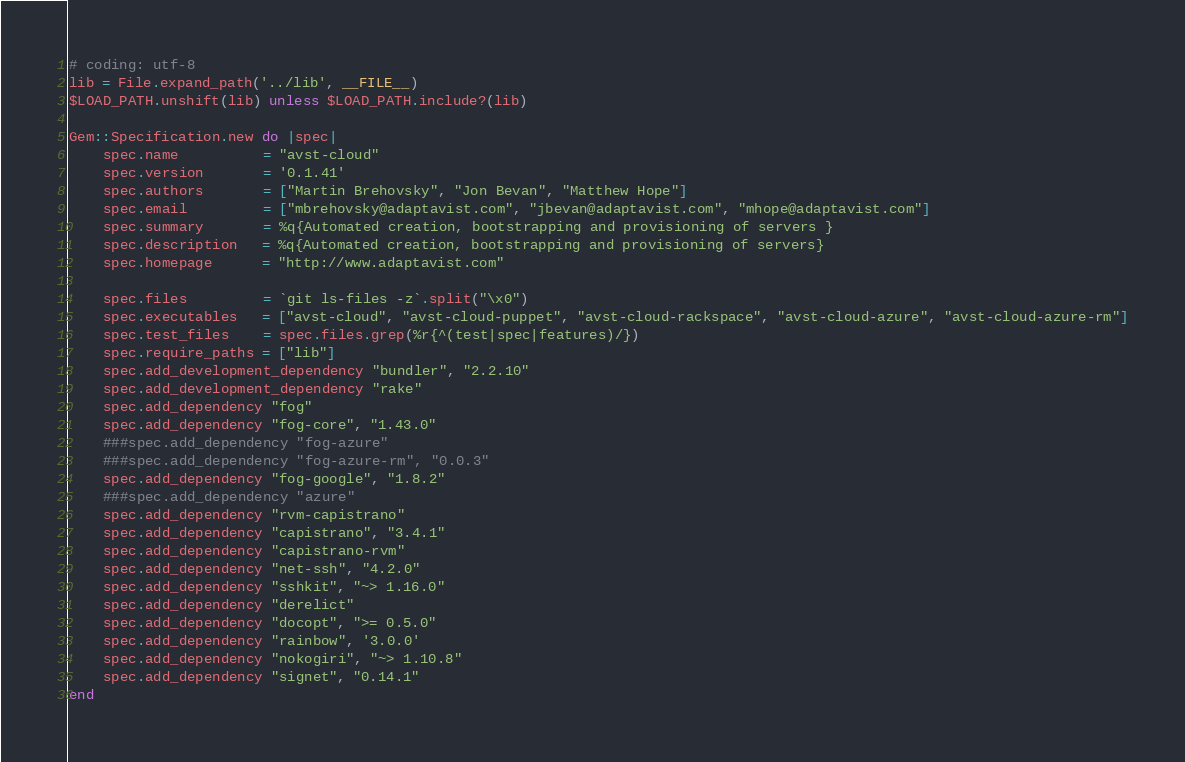Convert code to text. <code><loc_0><loc_0><loc_500><loc_500><_Ruby_># coding: utf-8
lib = File.expand_path('../lib', __FILE__)
$LOAD_PATH.unshift(lib) unless $LOAD_PATH.include?(lib)

Gem::Specification.new do |spec|
    spec.name          = "avst-cloud"
    spec.version       = '0.1.41'
    spec.authors       = ["Martin Brehovsky", "Jon Bevan", "Matthew Hope"]
    spec.email         = ["mbrehovsky@adaptavist.com", "jbevan@adaptavist.com", "mhope@adaptavist.com"]
    spec.summary       = %q{Automated creation, bootstrapping and provisioning of servers }
    spec.description   = %q{Automated creation, bootstrapping and provisioning of servers}
    spec.homepage      = "http://www.adaptavist.com"

    spec.files         = `git ls-files -z`.split("\x0")
    spec.executables   = ["avst-cloud", "avst-cloud-puppet", "avst-cloud-rackspace", "avst-cloud-azure", "avst-cloud-azure-rm"]
    spec.test_files    = spec.files.grep(%r{^(test|spec|features)/})
    spec.require_paths = ["lib"]
    spec.add_development_dependency "bundler", "2.2.10"
    spec.add_development_dependency "rake"
    spec.add_dependency "fog"
    spec.add_dependency "fog-core", "1.43.0"
    ###spec.add_dependency "fog-azure"
    ###spec.add_dependency "fog-azure-rm", "0.0.3"
    spec.add_dependency "fog-google", "1.8.2"
    ###spec.add_dependency "azure"
    spec.add_dependency "rvm-capistrano"
    spec.add_dependency "capistrano", "3.4.1"
    spec.add_dependency "capistrano-rvm"
    spec.add_dependency "net-ssh", "4.2.0"
    spec.add_dependency "sshkit", "~> 1.16.0"
    spec.add_dependency "derelict"
    spec.add_dependency "docopt", ">= 0.5.0"
    spec.add_dependency "rainbow", '3.0.0'
    spec.add_dependency "nokogiri", "~> 1.10.8"
    spec.add_dependency "signet", "0.14.1"
end


</code> 